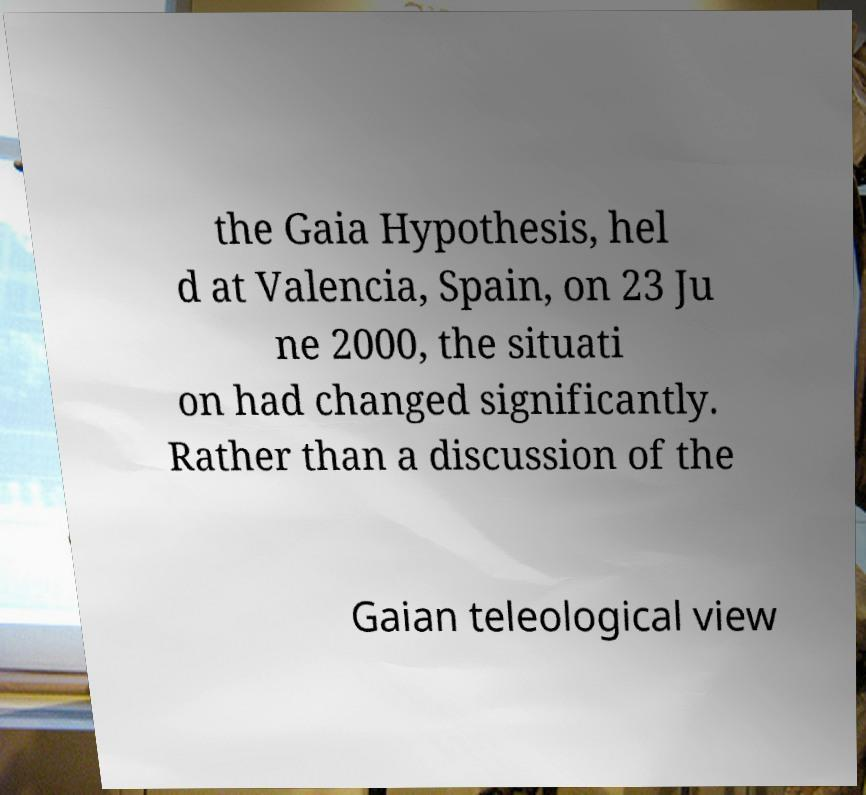Please read and relay the text visible in this image. What does it say? the Gaia Hypothesis, hel d at Valencia, Spain, on 23 Ju ne 2000, the situati on had changed significantly. Rather than a discussion of the Gaian teleological view 